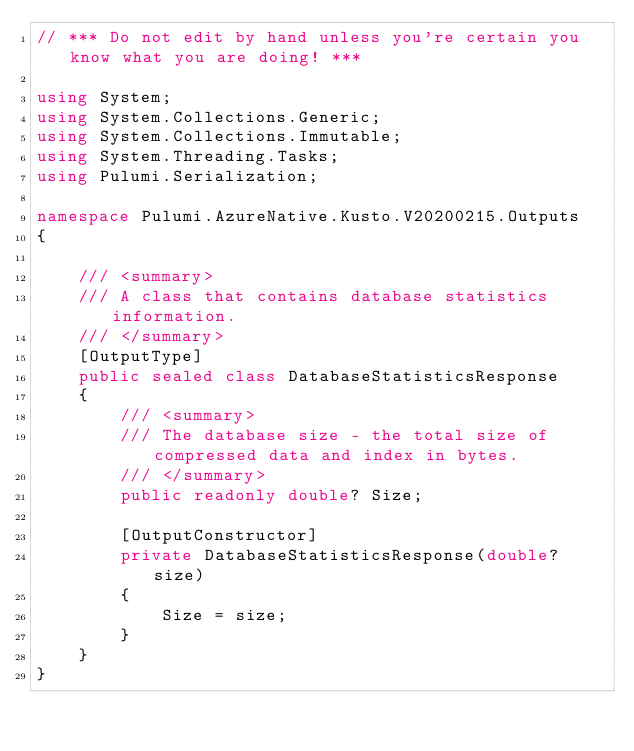<code> <loc_0><loc_0><loc_500><loc_500><_C#_>// *** Do not edit by hand unless you're certain you know what you are doing! ***

using System;
using System.Collections.Generic;
using System.Collections.Immutable;
using System.Threading.Tasks;
using Pulumi.Serialization;

namespace Pulumi.AzureNative.Kusto.V20200215.Outputs
{

    /// <summary>
    /// A class that contains database statistics information.
    /// </summary>
    [OutputType]
    public sealed class DatabaseStatisticsResponse
    {
        /// <summary>
        /// The database size - the total size of compressed data and index in bytes.
        /// </summary>
        public readonly double? Size;

        [OutputConstructor]
        private DatabaseStatisticsResponse(double? size)
        {
            Size = size;
        }
    }
}
</code> 